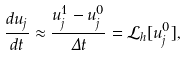<formula> <loc_0><loc_0><loc_500><loc_500>\frac { d u _ { j } } { d t } \approx \frac { u ^ { 1 } _ { j } - u ^ { 0 } _ { j } } { \Delta t } = \mathcal { L } _ { h } [ u ^ { 0 } _ { j } ] ,</formula> 